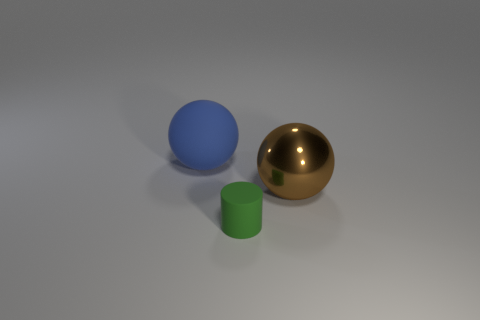What materials do the objects in the image appear to be made from? The objects in the image appear to have different materials. The reflective golden sphere looks like it could be made of polished metal. The matte green cylinder seems like it could be made of plastic or painted wood, and the matte blue ball could also be a sort of painted ceramic or plastic given its lack of shine and uniformly diffused light. 